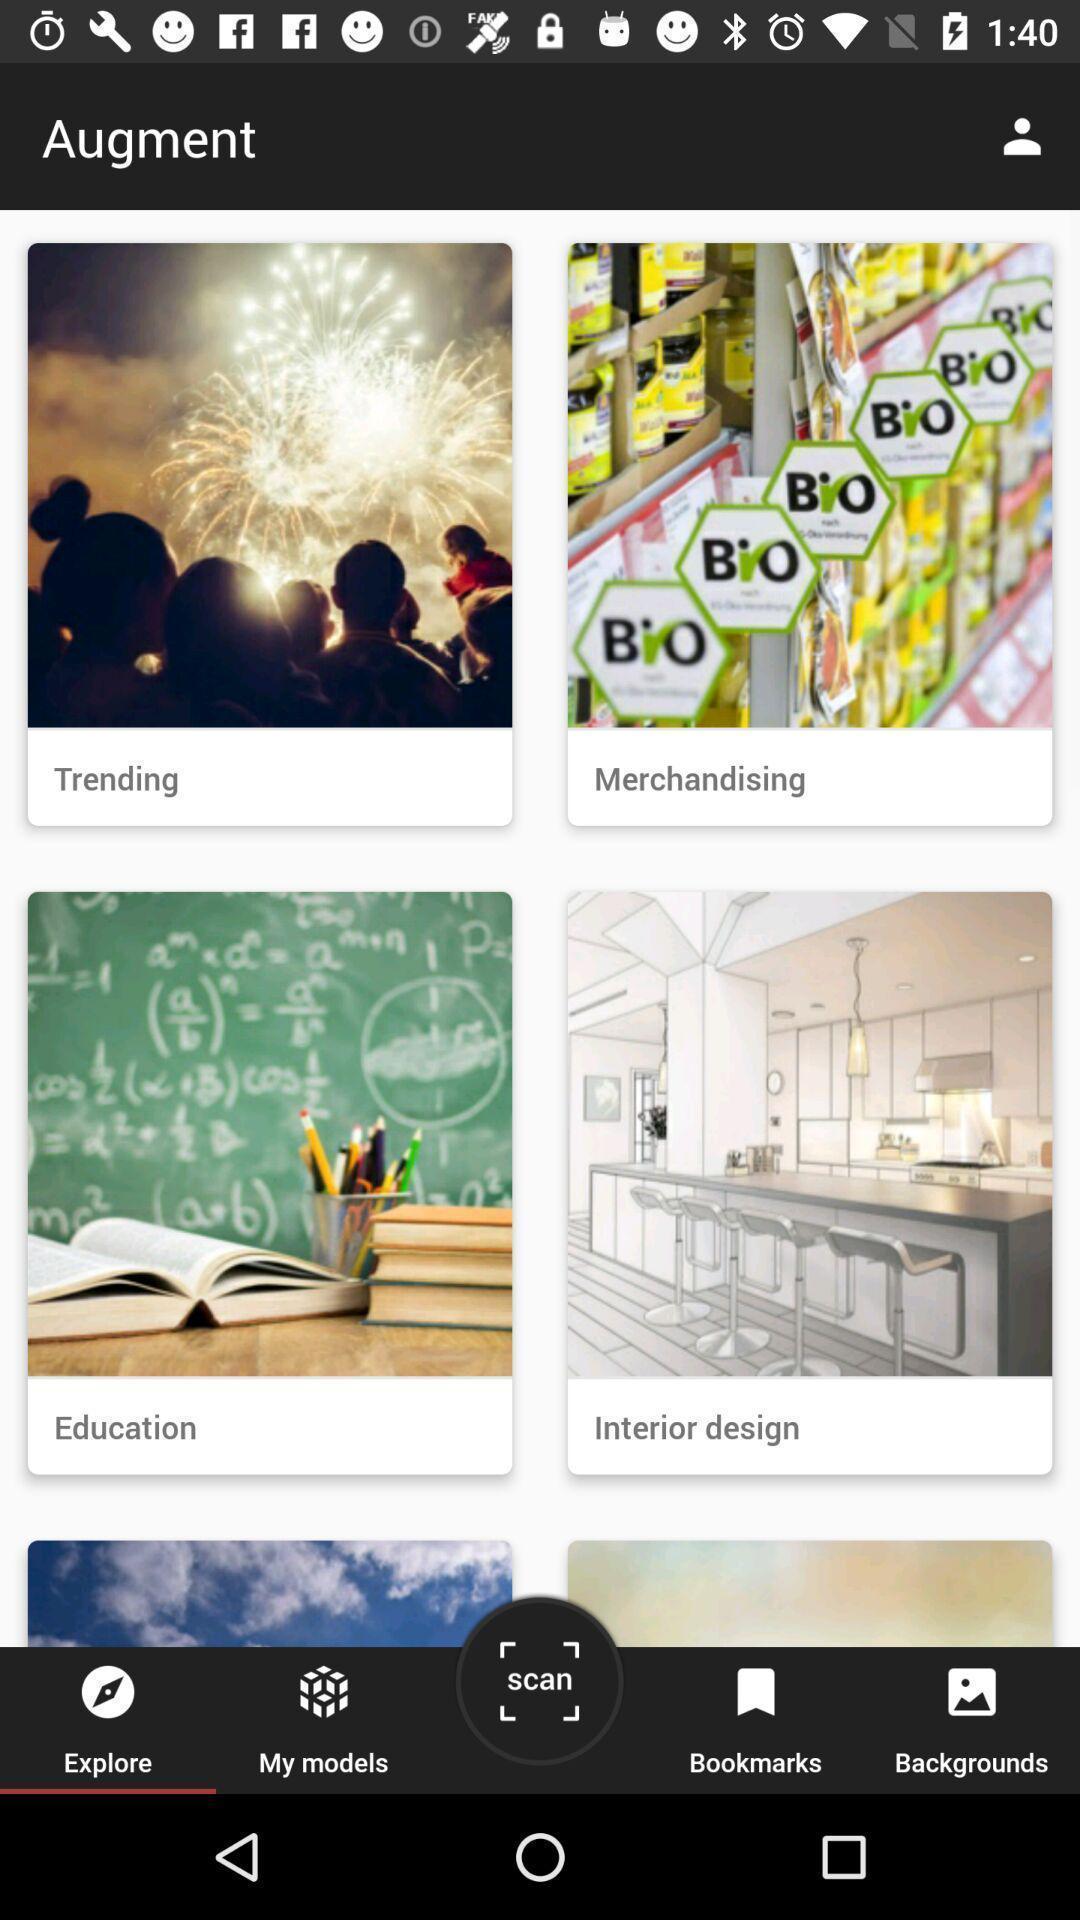Give me a narrative description of this picture. Page displaying different categories in app. 